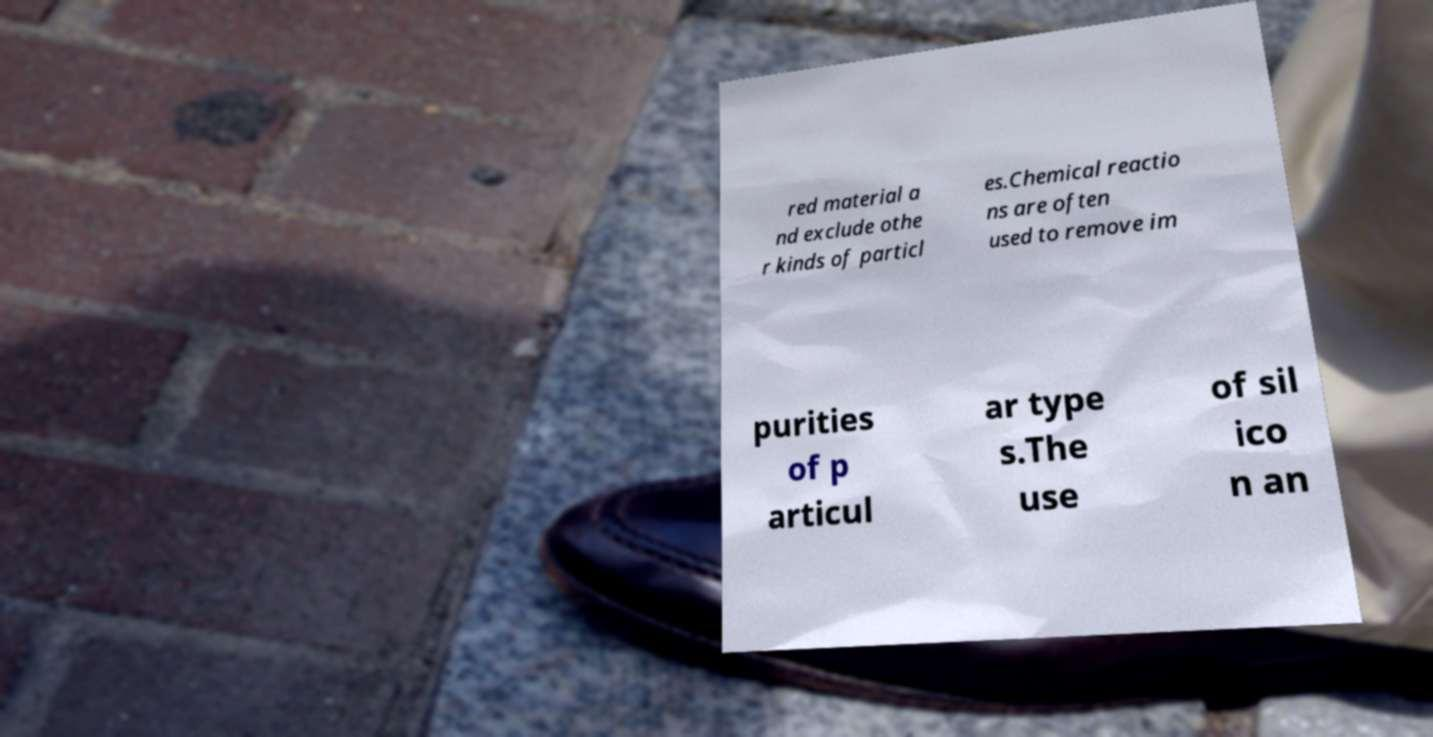Could you extract and type out the text from this image? red material a nd exclude othe r kinds of particl es.Chemical reactio ns are often used to remove im purities of p articul ar type s.The use of sil ico n an 